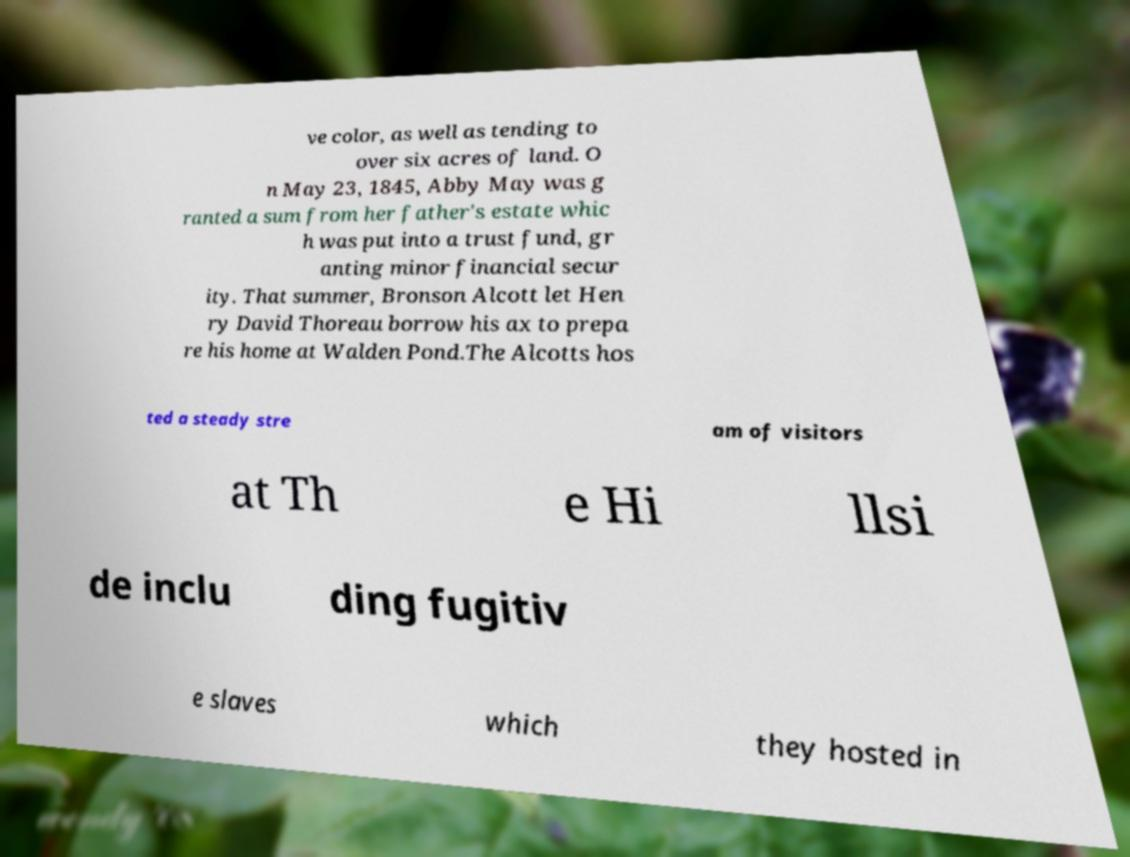Could you extract and type out the text from this image? ve color, as well as tending to over six acres of land. O n May 23, 1845, Abby May was g ranted a sum from her father's estate whic h was put into a trust fund, gr anting minor financial secur ity. That summer, Bronson Alcott let Hen ry David Thoreau borrow his ax to prepa re his home at Walden Pond.The Alcotts hos ted a steady stre am of visitors at Th e Hi llsi de inclu ding fugitiv e slaves which they hosted in 